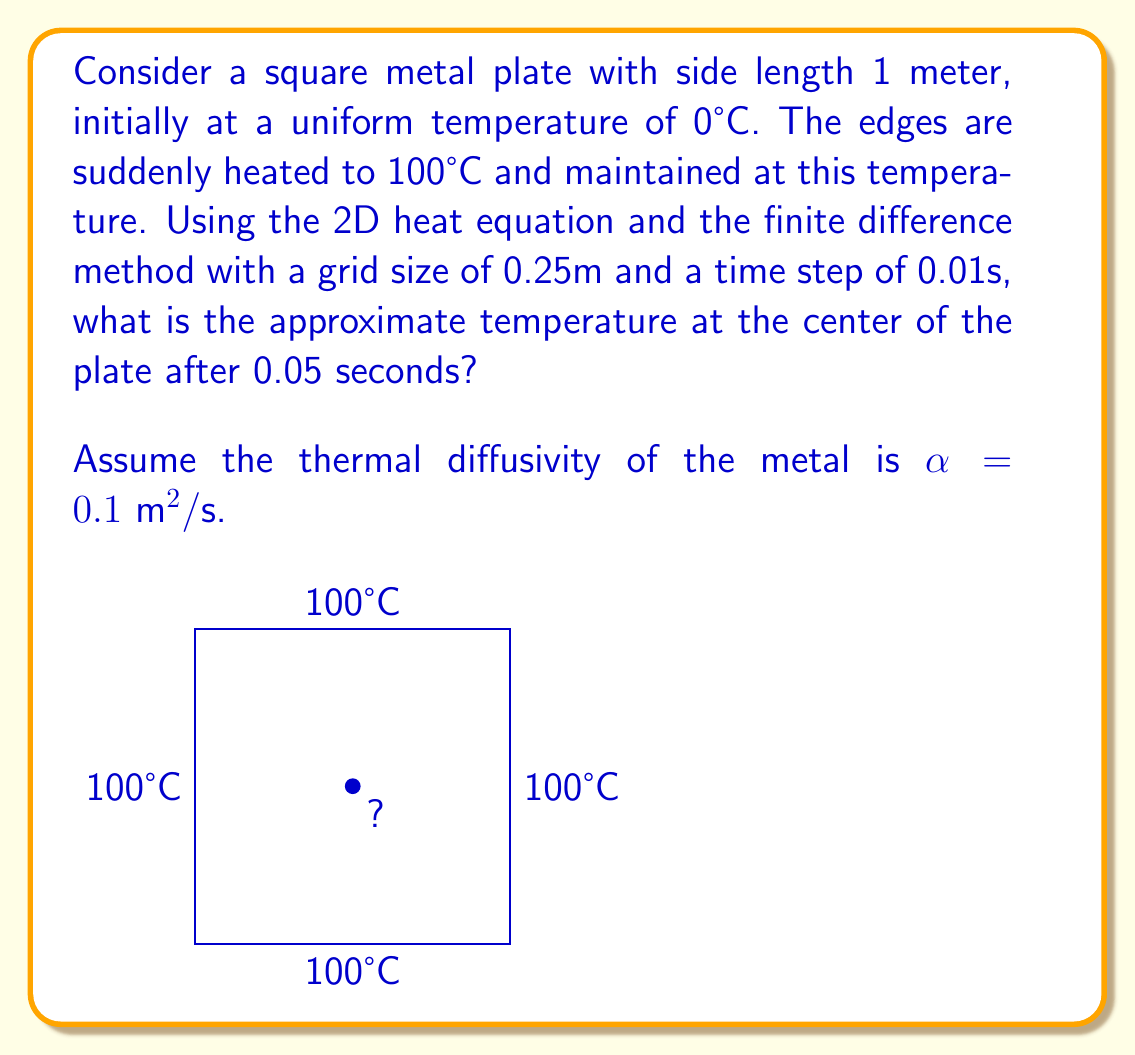Could you help me with this problem? To solve this problem, we'll use the 2D heat equation and the finite difference method:

1) The 2D heat equation is:

   $$\frac{\partial u}{\partial t} = \alpha \left(\frac{\partial^2 u}{\partial x^2} + \frac{\partial^2 u}{\partial y^2}\right)$$

2) Using the finite difference method, we can approximate this as:

   $$\frac{u_{i,j}^{n+1} - u_{i,j}^n}{\Delta t} = \alpha \left(\frac{u_{i+1,j}^n - 2u_{i,j}^n + u_{i-1,j}^n}{(\Delta x)^2} + \frac{u_{i,j+1}^n - 2u_{i,j}^n + u_{i,j-1}^n}{(\Delta y)^2}\right)$$

3) Rearranging for $u_{i,j}^{n+1}$:

   $$u_{i,j}^{n+1} = u_{i,j}^n + \frac{\alpha \Delta t}{(\Delta x)^2} (u_{i+1,j}^n + u_{i-1,j}^n + u_{i,j+1}^n + u_{i,j-1}^n - 4u_{i,j}^n)$$

4) Given:
   - $\Delta x = \Delta y = 0.25\text{ m}$
   - $\Delta t = 0.01\text{ s}$
   - $\alpha = 0.1 \text{ m}^2/\text{s}$

5) Calculate the coefficient:

   $$\frac{\alpha \Delta t}{(\Delta x)^2} = \frac{0.1 \cdot 0.01}{(0.25)^2} = 0.016$$

6) The center point is surrounded by four boundary points at 100°C. Initially, the center is at 0°C.

7) After the first time step:

   $$u_{1,1}^1 = 0 + 0.016(100 + 100 + 100 + 100 - 4 \cdot 0) = 6.4°C$$

8) After the second time step:

   $$u_{1,1}^2 = 6.4 + 0.016(100 + 100 + 100 + 100 - 4 \cdot 6.4) = 12.416°C$$

9) After the third time step:

   $$u_{1,1}^3 = 12.416 + 0.016(100 + 100 + 100 + 100 - 4 \cdot 12.416) = 18.080°C$$

10) After the fourth time step:

    $$u_{1,1}^4 = 18.080 + 0.016(100 + 100 + 100 + 100 - 4 \cdot 18.080) = 23.413°C$$

11) After the fifth time step:

    $$u_{1,1}^5 = 23.413 + 0.016(100 + 100 + 100 + 100 - 4 \cdot 23.413) = 28.434°C$$
Answer: $28.434°C$ 